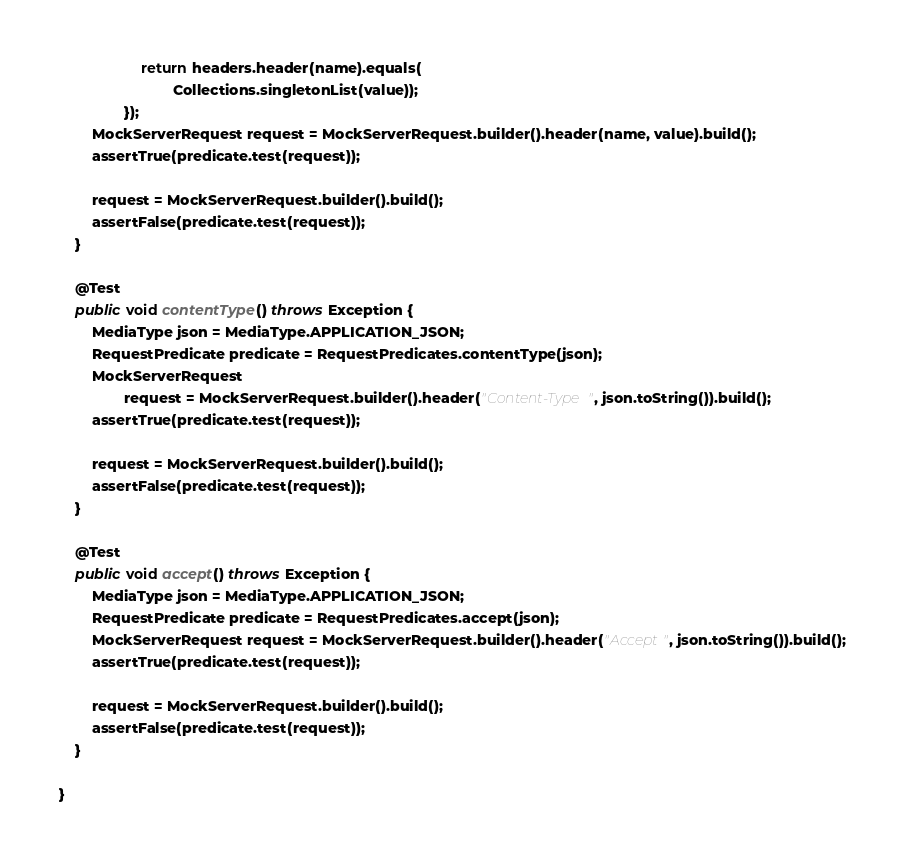<code> <loc_0><loc_0><loc_500><loc_500><_Java_>					return headers.header(name).equals(
							Collections.singletonList(value));
				});
		MockServerRequest request = MockServerRequest.builder().header(name, value).build();
		assertTrue(predicate.test(request));

		request = MockServerRequest.builder().build();
		assertFalse(predicate.test(request));
	}

	@Test
	public void contentType() throws Exception {
		MediaType json = MediaType.APPLICATION_JSON;
		RequestPredicate predicate = RequestPredicates.contentType(json);
		MockServerRequest
				request = MockServerRequest.builder().header("Content-Type", json.toString()).build();
		assertTrue(predicate.test(request));

		request = MockServerRequest.builder().build();
		assertFalse(predicate.test(request));
	}

	@Test
	public void accept() throws Exception {
		MediaType json = MediaType.APPLICATION_JSON;
		RequestPredicate predicate = RequestPredicates.accept(json);
		MockServerRequest request = MockServerRequest.builder().header("Accept", json.toString()).build();
		assertTrue(predicate.test(request));

		request = MockServerRequest.builder().build();
		assertFalse(predicate.test(request));
	}

}</code> 